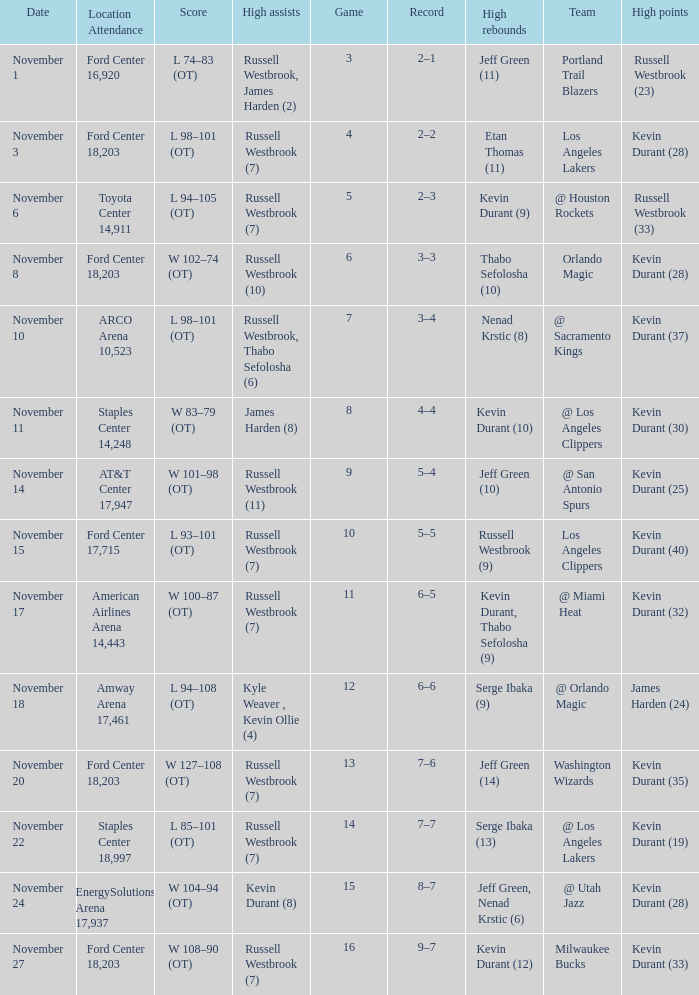What was the record in the game in which Jeff Green (14) did the most high rebounds? 7–6. 